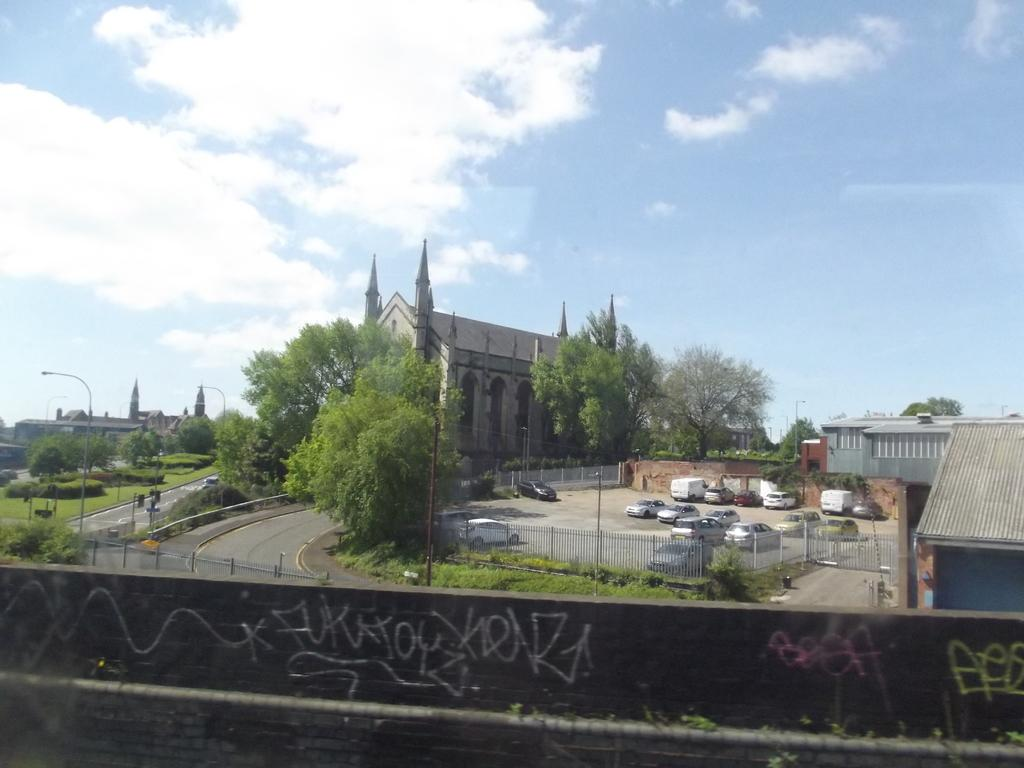Provide a one-sentence caption for the provided image. The word beef is written in pink spray paint on a stone wall. 